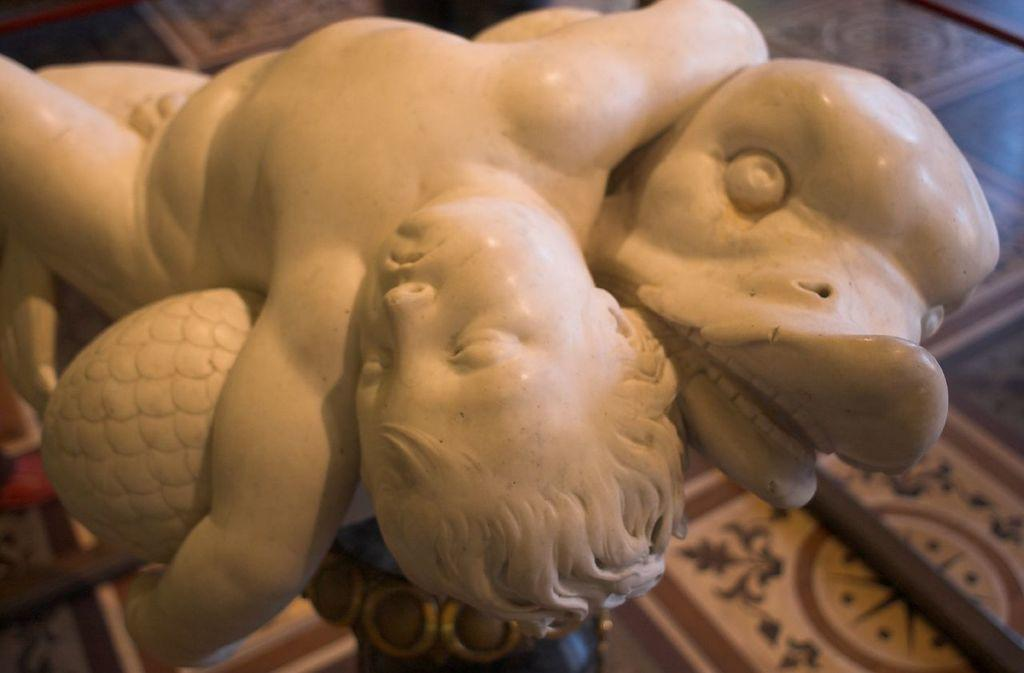What is the main subject of the image? There is a depiction of a boy in the center of the image. Is there anything else in the center of the image besides the boy? Yes, there is a depiction of an animal in the center of the image. What type of quill is the boy using to rub the deer in the image? There is no quill or deer present in the image; it only features a depiction of a boy and an animal. 